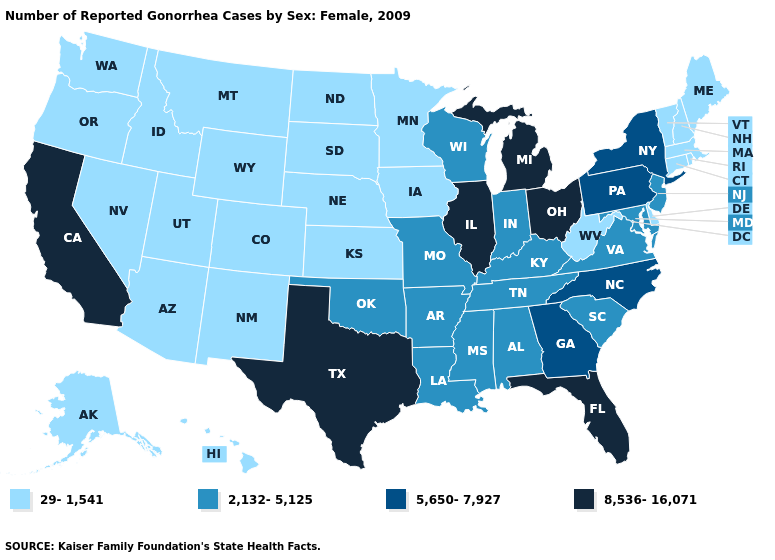Does South Carolina have a lower value than Illinois?
Answer briefly. Yes. What is the highest value in states that border Connecticut?
Keep it brief. 5,650-7,927. What is the highest value in the USA?
Write a very short answer. 8,536-16,071. Is the legend a continuous bar?
Concise answer only. No. What is the value of Michigan?
Be succinct. 8,536-16,071. Does the map have missing data?
Concise answer only. No. What is the value of West Virginia?
Concise answer only. 29-1,541. Does Massachusetts have the lowest value in the Northeast?
Quick response, please. Yes. Which states hav the highest value in the South?
Quick response, please. Florida, Texas. Which states have the lowest value in the MidWest?
Concise answer only. Iowa, Kansas, Minnesota, Nebraska, North Dakota, South Dakota. Among the states that border Rhode Island , which have the highest value?
Be succinct. Connecticut, Massachusetts. What is the lowest value in the MidWest?
Quick response, please. 29-1,541. Name the states that have a value in the range 2,132-5,125?
Concise answer only. Alabama, Arkansas, Indiana, Kentucky, Louisiana, Maryland, Mississippi, Missouri, New Jersey, Oklahoma, South Carolina, Tennessee, Virginia, Wisconsin. Which states have the lowest value in the West?
Quick response, please. Alaska, Arizona, Colorado, Hawaii, Idaho, Montana, Nevada, New Mexico, Oregon, Utah, Washington, Wyoming. Among the states that border New York , does Vermont have the lowest value?
Keep it brief. Yes. 